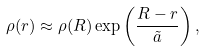Convert formula to latex. <formula><loc_0><loc_0><loc_500><loc_500>\rho ( r ) \approx \rho ( { R } ) \exp \left ( \frac { { R } - r } { \tilde { a } } \right ) ,</formula> 